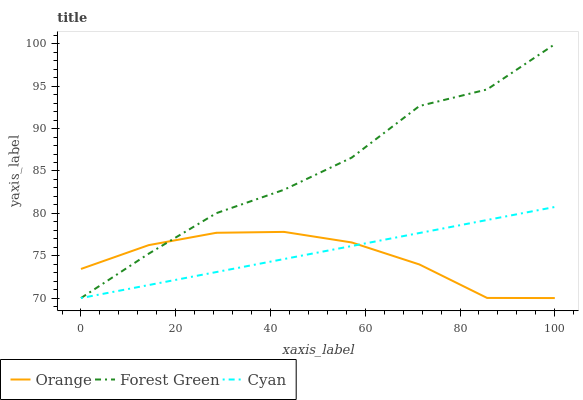Does Orange have the minimum area under the curve?
Answer yes or no. Yes. Does Forest Green have the maximum area under the curve?
Answer yes or no. Yes. Does Cyan have the minimum area under the curve?
Answer yes or no. No. Does Cyan have the maximum area under the curve?
Answer yes or no. No. Is Cyan the smoothest?
Answer yes or no. Yes. Is Forest Green the roughest?
Answer yes or no. Yes. Is Forest Green the smoothest?
Answer yes or no. No. Is Cyan the roughest?
Answer yes or no. No. Does Forest Green have the highest value?
Answer yes or no. Yes. Does Cyan have the highest value?
Answer yes or no. No. Does Forest Green intersect Orange?
Answer yes or no. Yes. Is Forest Green less than Orange?
Answer yes or no. No. Is Forest Green greater than Orange?
Answer yes or no. No. 